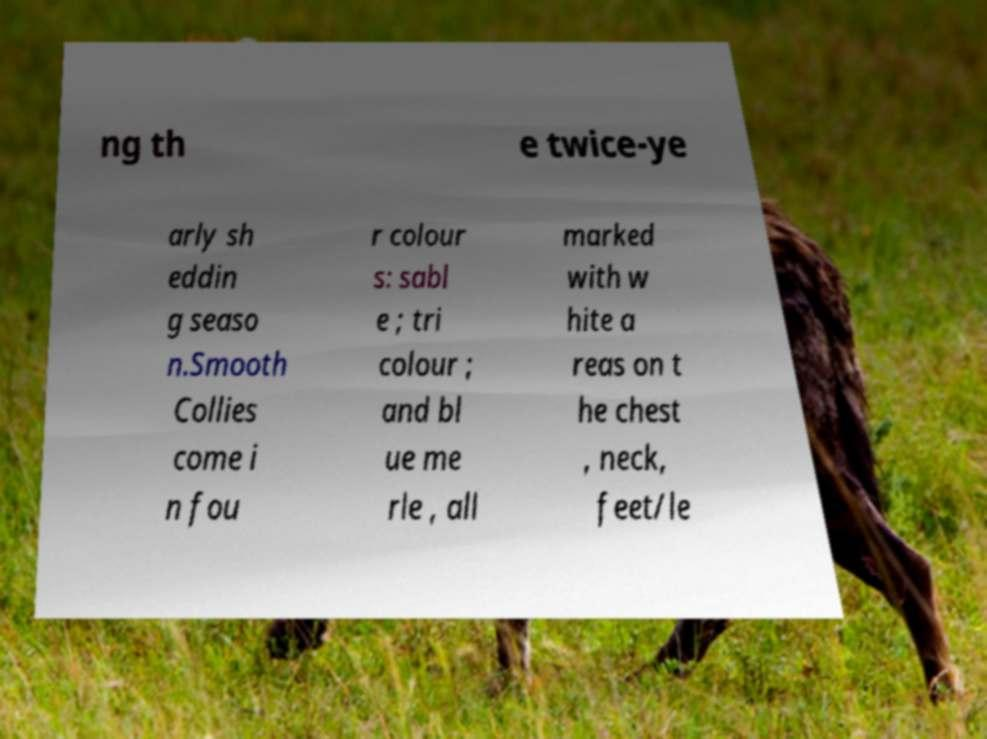Could you assist in decoding the text presented in this image and type it out clearly? ng th e twice-ye arly sh eddin g seaso n.Smooth Collies come i n fou r colour s: sabl e ; tri colour ; and bl ue me rle , all marked with w hite a reas on t he chest , neck, feet/le 